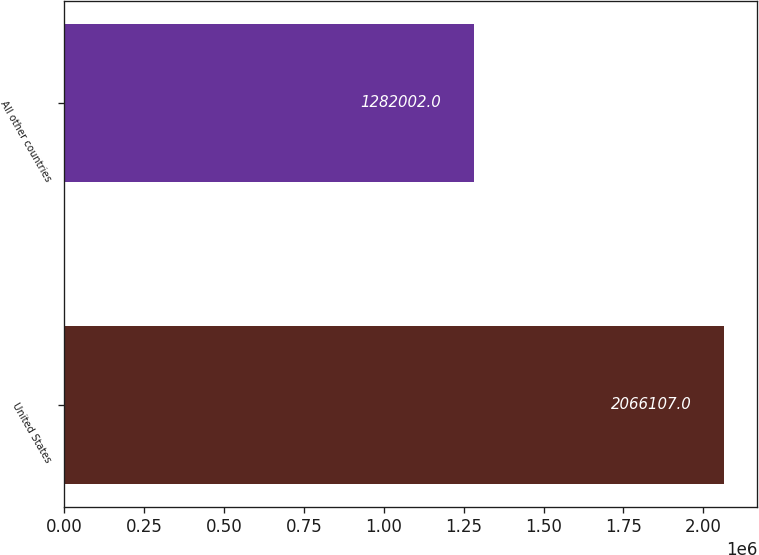Convert chart. <chart><loc_0><loc_0><loc_500><loc_500><bar_chart><fcel>United States<fcel>All other countries<nl><fcel>2.06611e+06<fcel>1.282e+06<nl></chart> 